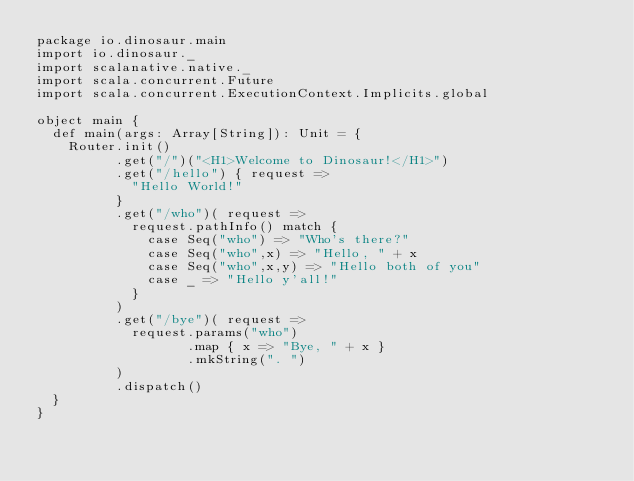Convert code to text. <code><loc_0><loc_0><loc_500><loc_500><_Scala_>package io.dinosaur.main
import io.dinosaur._
import scalanative.native._
import scala.concurrent.Future
import scala.concurrent.ExecutionContext.Implicits.global

object main {
  def main(args: Array[String]): Unit = {
    Router.init()
          .get("/")("<H1>Welcome to Dinosaur!</H1>")
          .get("/hello") { request =>
            "Hello World!"
          }
          .get("/who")( request =>
            request.pathInfo() match {
              case Seq("who") => "Who's there?"
              case Seq("who",x) => "Hello, " + x
              case Seq("who",x,y) => "Hello both of you"
              case _ => "Hello y'all!"
            }
          )
          .get("/bye")( request =>
            request.params("who")
                   .map { x => "Bye, " + x }
                   .mkString(". ")
          )
          .dispatch()
  }
}
</code> 